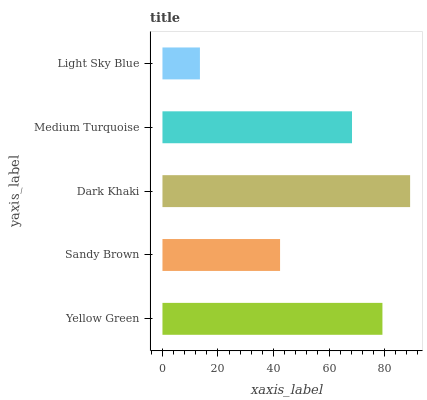Is Light Sky Blue the minimum?
Answer yes or no. Yes. Is Dark Khaki the maximum?
Answer yes or no. Yes. Is Sandy Brown the minimum?
Answer yes or no. No. Is Sandy Brown the maximum?
Answer yes or no. No. Is Yellow Green greater than Sandy Brown?
Answer yes or no. Yes. Is Sandy Brown less than Yellow Green?
Answer yes or no. Yes. Is Sandy Brown greater than Yellow Green?
Answer yes or no. No. Is Yellow Green less than Sandy Brown?
Answer yes or no. No. Is Medium Turquoise the high median?
Answer yes or no. Yes. Is Medium Turquoise the low median?
Answer yes or no. Yes. Is Yellow Green the high median?
Answer yes or no. No. Is Dark Khaki the low median?
Answer yes or no. No. 